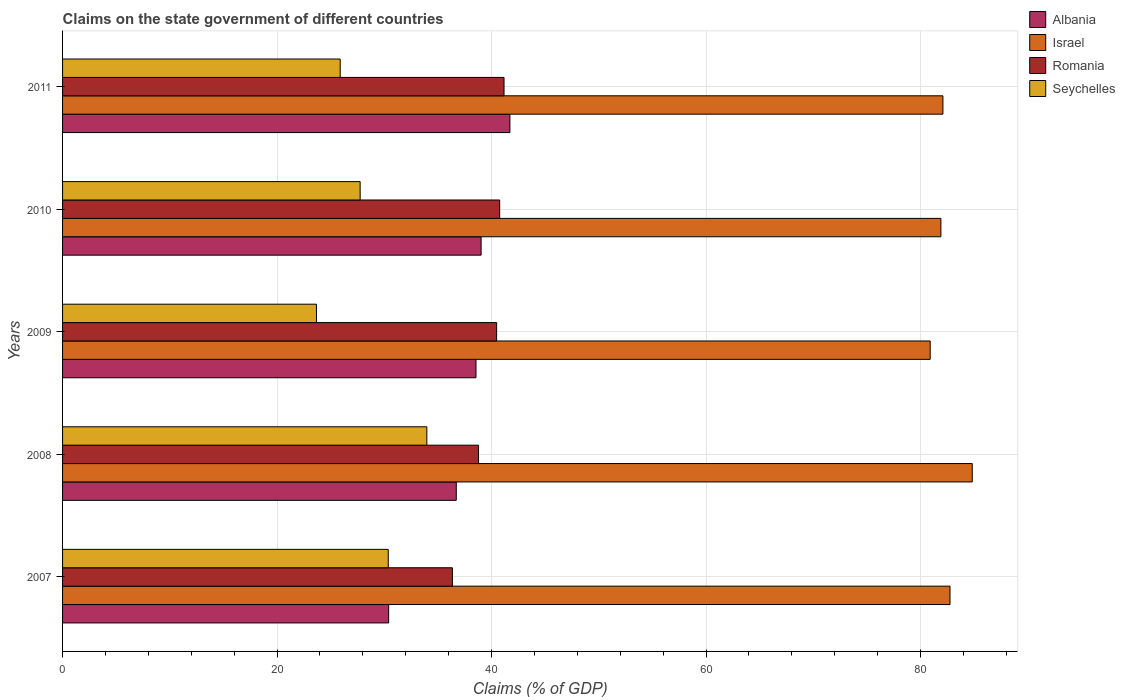How many groups of bars are there?
Give a very brief answer. 5. Are the number of bars on each tick of the Y-axis equal?
Make the answer very short. Yes. What is the percentage of GDP claimed on the state government in Israel in 2007?
Provide a short and direct response. 82.75. Across all years, what is the maximum percentage of GDP claimed on the state government in Seychelles?
Keep it short and to the point. 33.96. Across all years, what is the minimum percentage of GDP claimed on the state government in Israel?
Your response must be concise. 80.9. In which year was the percentage of GDP claimed on the state government in Romania maximum?
Provide a succinct answer. 2011. What is the total percentage of GDP claimed on the state government in Israel in the graph?
Make the answer very short. 412.44. What is the difference between the percentage of GDP claimed on the state government in Seychelles in 2007 and that in 2010?
Keep it short and to the point. 2.62. What is the difference between the percentage of GDP claimed on the state government in Israel in 2009 and the percentage of GDP claimed on the state government in Seychelles in 2007?
Make the answer very short. 50.53. What is the average percentage of GDP claimed on the state government in Seychelles per year?
Your answer should be very brief. 28.33. In the year 2011, what is the difference between the percentage of GDP claimed on the state government in Albania and percentage of GDP claimed on the state government in Romania?
Offer a terse response. 0.55. What is the ratio of the percentage of GDP claimed on the state government in Albania in 2010 to that in 2011?
Provide a short and direct response. 0.94. What is the difference between the highest and the second highest percentage of GDP claimed on the state government in Romania?
Your answer should be compact. 0.41. What is the difference between the highest and the lowest percentage of GDP claimed on the state government in Romania?
Your answer should be very brief. 4.82. In how many years, is the percentage of GDP claimed on the state government in Albania greater than the average percentage of GDP claimed on the state government in Albania taken over all years?
Your answer should be very brief. 3. What does the 3rd bar from the bottom in 2011 represents?
Make the answer very short. Romania. Is it the case that in every year, the sum of the percentage of GDP claimed on the state government in Israel and percentage of GDP claimed on the state government in Romania is greater than the percentage of GDP claimed on the state government in Seychelles?
Offer a terse response. Yes. Are all the bars in the graph horizontal?
Keep it short and to the point. Yes. How many years are there in the graph?
Your answer should be compact. 5. What is the difference between two consecutive major ticks on the X-axis?
Provide a succinct answer. 20. Does the graph contain any zero values?
Give a very brief answer. No. Does the graph contain grids?
Give a very brief answer. Yes. How many legend labels are there?
Your response must be concise. 4. What is the title of the graph?
Give a very brief answer. Claims on the state government of different countries. Does "Slovak Republic" appear as one of the legend labels in the graph?
Keep it short and to the point. No. What is the label or title of the X-axis?
Provide a succinct answer. Claims (% of GDP). What is the label or title of the Y-axis?
Offer a very short reply. Years. What is the Claims (% of GDP) of Albania in 2007?
Give a very brief answer. 30.41. What is the Claims (% of GDP) in Israel in 2007?
Give a very brief answer. 82.75. What is the Claims (% of GDP) of Romania in 2007?
Provide a short and direct response. 36.35. What is the Claims (% of GDP) of Seychelles in 2007?
Keep it short and to the point. 30.37. What is the Claims (% of GDP) of Albania in 2008?
Ensure brevity in your answer.  36.71. What is the Claims (% of GDP) of Israel in 2008?
Your answer should be compact. 84.82. What is the Claims (% of GDP) of Romania in 2008?
Provide a succinct answer. 38.78. What is the Claims (% of GDP) in Seychelles in 2008?
Make the answer very short. 33.96. What is the Claims (% of GDP) of Albania in 2009?
Offer a very short reply. 38.55. What is the Claims (% of GDP) in Israel in 2009?
Your response must be concise. 80.9. What is the Claims (% of GDP) of Romania in 2009?
Your answer should be compact. 40.47. What is the Claims (% of GDP) in Seychelles in 2009?
Offer a very short reply. 23.67. What is the Claims (% of GDP) of Albania in 2010?
Ensure brevity in your answer.  39.02. What is the Claims (% of GDP) of Israel in 2010?
Give a very brief answer. 81.89. What is the Claims (% of GDP) in Romania in 2010?
Your answer should be very brief. 40.76. What is the Claims (% of GDP) in Seychelles in 2010?
Ensure brevity in your answer.  27.75. What is the Claims (% of GDP) in Albania in 2011?
Your answer should be very brief. 41.71. What is the Claims (% of GDP) of Israel in 2011?
Make the answer very short. 82.08. What is the Claims (% of GDP) in Romania in 2011?
Keep it short and to the point. 41.16. What is the Claims (% of GDP) of Seychelles in 2011?
Ensure brevity in your answer.  25.89. Across all years, what is the maximum Claims (% of GDP) in Albania?
Offer a terse response. 41.71. Across all years, what is the maximum Claims (% of GDP) in Israel?
Keep it short and to the point. 84.82. Across all years, what is the maximum Claims (% of GDP) in Romania?
Keep it short and to the point. 41.16. Across all years, what is the maximum Claims (% of GDP) in Seychelles?
Offer a very short reply. 33.96. Across all years, what is the minimum Claims (% of GDP) in Albania?
Provide a succinct answer. 30.41. Across all years, what is the minimum Claims (% of GDP) of Israel?
Provide a succinct answer. 80.9. Across all years, what is the minimum Claims (% of GDP) of Romania?
Provide a succinct answer. 36.35. Across all years, what is the minimum Claims (% of GDP) in Seychelles?
Your response must be concise. 23.67. What is the total Claims (% of GDP) in Albania in the graph?
Your answer should be compact. 186.4. What is the total Claims (% of GDP) of Israel in the graph?
Ensure brevity in your answer.  412.44. What is the total Claims (% of GDP) in Romania in the graph?
Offer a very short reply. 197.52. What is the total Claims (% of GDP) of Seychelles in the graph?
Keep it short and to the point. 141.64. What is the difference between the Claims (% of GDP) of Albania in 2007 and that in 2008?
Your response must be concise. -6.3. What is the difference between the Claims (% of GDP) in Israel in 2007 and that in 2008?
Your answer should be very brief. -2.07. What is the difference between the Claims (% of GDP) in Romania in 2007 and that in 2008?
Provide a short and direct response. -2.44. What is the difference between the Claims (% of GDP) of Seychelles in 2007 and that in 2008?
Offer a very short reply. -3.6. What is the difference between the Claims (% of GDP) of Albania in 2007 and that in 2009?
Make the answer very short. -8.14. What is the difference between the Claims (% of GDP) in Israel in 2007 and that in 2009?
Your response must be concise. 1.85. What is the difference between the Claims (% of GDP) of Romania in 2007 and that in 2009?
Offer a very short reply. -4.12. What is the difference between the Claims (% of GDP) in Seychelles in 2007 and that in 2009?
Keep it short and to the point. 6.69. What is the difference between the Claims (% of GDP) in Albania in 2007 and that in 2010?
Give a very brief answer. -8.62. What is the difference between the Claims (% of GDP) in Israel in 2007 and that in 2010?
Keep it short and to the point. 0.85. What is the difference between the Claims (% of GDP) of Romania in 2007 and that in 2010?
Provide a short and direct response. -4.41. What is the difference between the Claims (% of GDP) in Seychelles in 2007 and that in 2010?
Offer a terse response. 2.62. What is the difference between the Claims (% of GDP) of Albania in 2007 and that in 2011?
Offer a very short reply. -11.31. What is the difference between the Claims (% of GDP) in Israel in 2007 and that in 2011?
Your answer should be very brief. 0.66. What is the difference between the Claims (% of GDP) of Romania in 2007 and that in 2011?
Keep it short and to the point. -4.82. What is the difference between the Claims (% of GDP) in Seychelles in 2007 and that in 2011?
Your answer should be compact. 4.48. What is the difference between the Claims (% of GDP) of Albania in 2008 and that in 2009?
Provide a short and direct response. -1.84. What is the difference between the Claims (% of GDP) of Israel in 2008 and that in 2009?
Ensure brevity in your answer.  3.92. What is the difference between the Claims (% of GDP) of Romania in 2008 and that in 2009?
Offer a very short reply. -1.69. What is the difference between the Claims (% of GDP) of Seychelles in 2008 and that in 2009?
Provide a succinct answer. 10.29. What is the difference between the Claims (% of GDP) in Albania in 2008 and that in 2010?
Your response must be concise. -2.31. What is the difference between the Claims (% of GDP) in Israel in 2008 and that in 2010?
Your response must be concise. 2.92. What is the difference between the Claims (% of GDP) in Romania in 2008 and that in 2010?
Provide a short and direct response. -1.97. What is the difference between the Claims (% of GDP) in Seychelles in 2008 and that in 2010?
Your answer should be compact. 6.22. What is the difference between the Claims (% of GDP) of Albania in 2008 and that in 2011?
Your answer should be very brief. -5. What is the difference between the Claims (% of GDP) of Israel in 2008 and that in 2011?
Your response must be concise. 2.73. What is the difference between the Claims (% of GDP) in Romania in 2008 and that in 2011?
Ensure brevity in your answer.  -2.38. What is the difference between the Claims (% of GDP) of Seychelles in 2008 and that in 2011?
Ensure brevity in your answer.  8.08. What is the difference between the Claims (% of GDP) of Albania in 2009 and that in 2010?
Your response must be concise. -0.48. What is the difference between the Claims (% of GDP) of Israel in 2009 and that in 2010?
Your answer should be compact. -1. What is the difference between the Claims (% of GDP) in Romania in 2009 and that in 2010?
Offer a very short reply. -0.28. What is the difference between the Claims (% of GDP) in Seychelles in 2009 and that in 2010?
Make the answer very short. -4.07. What is the difference between the Claims (% of GDP) in Albania in 2009 and that in 2011?
Your answer should be very brief. -3.16. What is the difference between the Claims (% of GDP) in Israel in 2009 and that in 2011?
Your response must be concise. -1.19. What is the difference between the Claims (% of GDP) of Romania in 2009 and that in 2011?
Your answer should be compact. -0.69. What is the difference between the Claims (% of GDP) in Seychelles in 2009 and that in 2011?
Your answer should be compact. -2.21. What is the difference between the Claims (% of GDP) of Albania in 2010 and that in 2011?
Provide a short and direct response. -2.69. What is the difference between the Claims (% of GDP) of Israel in 2010 and that in 2011?
Keep it short and to the point. -0.19. What is the difference between the Claims (% of GDP) of Romania in 2010 and that in 2011?
Keep it short and to the point. -0.41. What is the difference between the Claims (% of GDP) in Seychelles in 2010 and that in 2011?
Provide a short and direct response. 1.86. What is the difference between the Claims (% of GDP) of Albania in 2007 and the Claims (% of GDP) of Israel in 2008?
Ensure brevity in your answer.  -54.41. What is the difference between the Claims (% of GDP) in Albania in 2007 and the Claims (% of GDP) in Romania in 2008?
Ensure brevity in your answer.  -8.38. What is the difference between the Claims (% of GDP) of Albania in 2007 and the Claims (% of GDP) of Seychelles in 2008?
Keep it short and to the point. -3.56. What is the difference between the Claims (% of GDP) of Israel in 2007 and the Claims (% of GDP) of Romania in 2008?
Ensure brevity in your answer.  43.96. What is the difference between the Claims (% of GDP) of Israel in 2007 and the Claims (% of GDP) of Seychelles in 2008?
Provide a succinct answer. 48.78. What is the difference between the Claims (% of GDP) of Romania in 2007 and the Claims (% of GDP) of Seychelles in 2008?
Offer a terse response. 2.38. What is the difference between the Claims (% of GDP) in Albania in 2007 and the Claims (% of GDP) in Israel in 2009?
Make the answer very short. -50.49. What is the difference between the Claims (% of GDP) of Albania in 2007 and the Claims (% of GDP) of Romania in 2009?
Offer a very short reply. -10.07. What is the difference between the Claims (% of GDP) of Albania in 2007 and the Claims (% of GDP) of Seychelles in 2009?
Provide a short and direct response. 6.73. What is the difference between the Claims (% of GDP) in Israel in 2007 and the Claims (% of GDP) in Romania in 2009?
Make the answer very short. 42.27. What is the difference between the Claims (% of GDP) in Israel in 2007 and the Claims (% of GDP) in Seychelles in 2009?
Keep it short and to the point. 59.07. What is the difference between the Claims (% of GDP) in Romania in 2007 and the Claims (% of GDP) in Seychelles in 2009?
Your answer should be compact. 12.67. What is the difference between the Claims (% of GDP) of Albania in 2007 and the Claims (% of GDP) of Israel in 2010?
Your response must be concise. -51.49. What is the difference between the Claims (% of GDP) in Albania in 2007 and the Claims (% of GDP) in Romania in 2010?
Give a very brief answer. -10.35. What is the difference between the Claims (% of GDP) of Albania in 2007 and the Claims (% of GDP) of Seychelles in 2010?
Give a very brief answer. 2.66. What is the difference between the Claims (% of GDP) of Israel in 2007 and the Claims (% of GDP) of Romania in 2010?
Give a very brief answer. 41.99. What is the difference between the Claims (% of GDP) of Israel in 2007 and the Claims (% of GDP) of Seychelles in 2010?
Your answer should be very brief. 55. What is the difference between the Claims (% of GDP) in Romania in 2007 and the Claims (% of GDP) in Seychelles in 2010?
Provide a short and direct response. 8.6. What is the difference between the Claims (% of GDP) in Albania in 2007 and the Claims (% of GDP) in Israel in 2011?
Your answer should be very brief. -51.68. What is the difference between the Claims (% of GDP) of Albania in 2007 and the Claims (% of GDP) of Romania in 2011?
Ensure brevity in your answer.  -10.76. What is the difference between the Claims (% of GDP) of Albania in 2007 and the Claims (% of GDP) of Seychelles in 2011?
Keep it short and to the point. 4.52. What is the difference between the Claims (% of GDP) in Israel in 2007 and the Claims (% of GDP) in Romania in 2011?
Offer a terse response. 41.58. What is the difference between the Claims (% of GDP) in Israel in 2007 and the Claims (% of GDP) in Seychelles in 2011?
Give a very brief answer. 56.86. What is the difference between the Claims (% of GDP) in Romania in 2007 and the Claims (% of GDP) in Seychelles in 2011?
Your answer should be very brief. 10.46. What is the difference between the Claims (% of GDP) in Albania in 2008 and the Claims (% of GDP) in Israel in 2009?
Ensure brevity in your answer.  -44.19. What is the difference between the Claims (% of GDP) of Albania in 2008 and the Claims (% of GDP) of Romania in 2009?
Keep it short and to the point. -3.76. What is the difference between the Claims (% of GDP) in Albania in 2008 and the Claims (% of GDP) in Seychelles in 2009?
Offer a very short reply. 13.04. What is the difference between the Claims (% of GDP) in Israel in 2008 and the Claims (% of GDP) in Romania in 2009?
Make the answer very short. 44.35. What is the difference between the Claims (% of GDP) of Israel in 2008 and the Claims (% of GDP) of Seychelles in 2009?
Offer a very short reply. 61.14. What is the difference between the Claims (% of GDP) in Romania in 2008 and the Claims (% of GDP) in Seychelles in 2009?
Offer a very short reply. 15.11. What is the difference between the Claims (% of GDP) of Albania in 2008 and the Claims (% of GDP) of Israel in 2010?
Make the answer very short. -45.19. What is the difference between the Claims (% of GDP) of Albania in 2008 and the Claims (% of GDP) of Romania in 2010?
Make the answer very short. -4.05. What is the difference between the Claims (% of GDP) of Albania in 2008 and the Claims (% of GDP) of Seychelles in 2010?
Provide a succinct answer. 8.96. What is the difference between the Claims (% of GDP) in Israel in 2008 and the Claims (% of GDP) in Romania in 2010?
Provide a short and direct response. 44.06. What is the difference between the Claims (% of GDP) in Israel in 2008 and the Claims (% of GDP) in Seychelles in 2010?
Provide a short and direct response. 57.07. What is the difference between the Claims (% of GDP) in Romania in 2008 and the Claims (% of GDP) in Seychelles in 2010?
Provide a short and direct response. 11.04. What is the difference between the Claims (% of GDP) of Albania in 2008 and the Claims (% of GDP) of Israel in 2011?
Ensure brevity in your answer.  -45.38. What is the difference between the Claims (% of GDP) of Albania in 2008 and the Claims (% of GDP) of Romania in 2011?
Provide a succinct answer. -4.45. What is the difference between the Claims (% of GDP) of Albania in 2008 and the Claims (% of GDP) of Seychelles in 2011?
Provide a succinct answer. 10.82. What is the difference between the Claims (% of GDP) of Israel in 2008 and the Claims (% of GDP) of Romania in 2011?
Your answer should be very brief. 43.65. What is the difference between the Claims (% of GDP) of Israel in 2008 and the Claims (% of GDP) of Seychelles in 2011?
Make the answer very short. 58.93. What is the difference between the Claims (% of GDP) of Romania in 2008 and the Claims (% of GDP) of Seychelles in 2011?
Provide a short and direct response. 12.9. What is the difference between the Claims (% of GDP) of Albania in 2009 and the Claims (% of GDP) of Israel in 2010?
Provide a short and direct response. -43.35. What is the difference between the Claims (% of GDP) of Albania in 2009 and the Claims (% of GDP) of Romania in 2010?
Your response must be concise. -2.21. What is the difference between the Claims (% of GDP) of Albania in 2009 and the Claims (% of GDP) of Seychelles in 2010?
Your answer should be very brief. 10.8. What is the difference between the Claims (% of GDP) in Israel in 2009 and the Claims (% of GDP) in Romania in 2010?
Your answer should be very brief. 40.14. What is the difference between the Claims (% of GDP) of Israel in 2009 and the Claims (% of GDP) of Seychelles in 2010?
Provide a succinct answer. 53.15. What is the difference between the Claims (% of GDP) in Romania in 2009 and the Claims (% of GDP) in Seychelles in 2010?
Give a very brief answer. 12.73. What is the difference between the Claims (% of GDP) in Albania in 2009 and the Claims (% of GDP) in Israel in 2011?
Ensure brevity in your answer.  -43.54. What is the difference between the Claims (% of GDP) in Albania in 2009 and the Claims (% of GDP) in Romania in 2011?
Keep it short and to the point. -2.62. What is the difference between the Claims (% of GDP) in Albania in 2009 and the Claims (% of GDP) in Seychelles in 2011?
Ensure brevity in your answer.  12.66. What is the difference between the Claims (% of GDP) of Israel in 2009 and the Claims (% of GDP) of Romania in 2011?
Keep it short and to the point. 39.73. What is the difference between the Claims (% of GDP) of Israel in 2009 and the Claims (% of GDP) of Seychelles in 2011?
Your response must be concise. 55.01. What is the difference between the Claims (% of GDP) of Romania in 2009 and the Claims (% of GDP) of Seychelles in 2011?
Your answer should be compact. 14.58. What is the difference between the Claims (% of GDP) of Albania in 2010 and the Claims (% of GDP) of Israel in 2011?
Provide a short and direct response. -43.06. What is the difference between the Claims (% of GDP) in Albania in 2010 and the Claims (% of GDP) in Romania in 2011?
Provide a short and direct response. -2.14. What is the difference between the Claims (% of GDP) in Albania in 2010 and the Claims (% of GDP) in Seychelles in 2011?
Provide a succinct answer. 13.14. What is the difference between the Claims (% of GDP) of Israel in 2010 and the Claims (% of GDP) of Romania in 2011?
Offer a very short reply. 40.73. What is the difference between the Claims (% of GDP) in Israel in 2010 and the Claims (% of GDP) in Seychelles in 2011?
Your response must be concise. 56.01. What is the difference between the Claims (% of GDP) in Romania in 2010 and the Claims (% of GDP) in Seychelles in 2011?
Keep it short and to the point. 14.87. What is the average Claims (% of GDP) in Albania per year?
Make the answer very short. 37.28. What is the average Claims (% of GDP) in Israel per year?
Your response must be concise. 82.49. What is the average Claims (% of GDP) of Romania per year?
Provide a short and direct response. 39.5. What is the average Claims (% of GDP) in Seychelles per year?
Provide a succinct answer. 28.33. In the year 2007, what is the difference between the Claims (% of GDP) of Albania and Claims (% of GDP) of Israel?
Ensure brevity in your answer.  -52.34. In the year 2007, what is the difference between the Claims (% of GDP) in Albania and Claims (% of GDP) in Romania?
Provide a short and direct response. -5.94. In the year 2007, what is the difference between the Claims (% of GDP) of Albania and Claims (% of GDP) of Seychelles?
Your response must be concise. 0.04. In the year 2007, what is the difference between the Claims (% of GDP) of Israel and Claims (% of GDP) of Romania?
Your answer should be compact. 46.4. In the year 2007, what is the difference between the Claims (% of GDP) in Israel and Claims (% of GDP) in Seychelles?
Offer a terse response. 52.38. In the year 2007, what is the difference between the Claims (% of GDP) in Romania and Claims (% of GDP) in Seychelles?
Keep it short and to the point. 5.98. In the year 2008, what is the difference between the Claims (% of GDP) in Albania and Claims (% of GDP) in Israel?
Your answer should be compact. -48.11. In the year 2008, what is the difference between the Claims (% of GDP) in Albania and Claims (% of GDP) in Romania?
Give a very brief answer. -2.08. In the year 2008, what is the difference between the Claims (% of GDP) in Albania and Claims (% of GDP) in Seychelles?
Your response must be concise. 2.75. In the year 2008, what is the difference between the Claims (% of GDP) in Israel and Claims (% of GDP) in Romania?
Keep it short and to the point. 46.03. In the year 2008, what is the difference between the Claims (% of GDP) in Israel and Claims (% of GDP) in Seychelles?
Offer a very short reply. 50.85. In the year 2008, what is the difference between the Claims (% of GDP) of Romania and Claims (% of GDP) of Seychelles?
Keep it short and to the point. 4.82. In the year 2009, what is the difference between the Claims (% of GDP) in Albania and Claims (% of GDP) in Israel?
Make the answer very short. -42.35. In the year 2009, what is the difference between the Claims (% of GDP) in Albania and Claims (% of GDP) in Romania?
Make the answer very short. -1.92. In the year 2009, what is the difference between the Claims (% of GDP) in Albania and Claims (% of GDP) in Seychelles?
Offer a terse response. 14.87. In the year 2009, what is the difference between the Claims (% of GDP) of Israel and Claims (% of GDP) of Romania?
Your answer should be very brief. 40.42. In the year 2009, what is the difference between the Claims (% of GDP) in Israel and Claims (% of GDP) in Seychelles?
Keep it short and to the point. 57.22. In the year 2009, what is the difference between the Claims (% of GDP) of Romania and Claims (% of GDP) of Seychelles?
Keep it short and to the point. 16.8. In the year 2010, what is the difference between the Claims (% of GDP) of Albania and Claims (% of GDP) of Israel?
Provide a short and direct response. -42.87. In the year 2010, what is the difference between the Claims (% of GDP) of Albania and Claims (% of GDP) of Romania?
Keep it short and to the point. -1.73. In the year 2010, what is the difference between the Claims (% of GDP) in Albania and Claims (% of GDP) in Seychelles?
Your answer should be very brief. 11.28. In the year 2010, what is the difference between the Claims (% of GDP) in Israel and Claims (% of GDP) in Romania?
Ensure brevity in your answer.  41.14. In the year 2010, what is the difference between the Claims (% of GDP) of Israel and Claims (% of GDP) of Seychelles?
Offer a very short reply. 54.15. In the year 2010, what is the difference between the Claims (% of GDP) of Romania and Claims (% of GDP) of Seychelles?
Provide a short and direct response. 13.01. In the year 2011, what is the difference between the Claims (% of GDP) of Albania and Claims (% of GDP) of Israel?
Keep it short and to the point. -40.37. In the year 2011, what is the difference between the Claims (% of GDP) in Albania and Claims (% of GDP) in Romania?
Your response must be concise. 0.55. In the year 2011, what is the difference between the Claims (% of GDP) in Albania and Claims (% of GDP) in Seychelles?
Your response must be concise. 15.82. In the year 2011, what is the difference between the Claims (% of GDP) of Israel and Claims (% of GDP) of Romania?
Your answer should be very brief. 40.92. In the year 2011, what is the difference between the Claims (% of GDP) of Israel and Claims (% of GDP) of Seychelles?
Give a very brief answer. 56.2. In the year 2011, what is the difference between the Claims (% of GDP) of Romania and Claims (% of GDP) of Seychelles?
Provide a short and direct response. 15.28. What is the ratio of the Claims (% of GDP) in Albania in 2007 to that in 2008?
Give a very brief answer. 0.83. What is the ratio of the Claims (% of GDP) of Israel in 2007 to that in 2008?
Ensure brevity in your answer.  0.98. What is the ratio of the Claims (% of GDP) in Romania in 2007 to that in 2008?
Offer a very short reply. 0.94. What is the ratio of the Claims (% of GDP) in Seychelles in 2007 to that in 2008?
Make the answer very short. 0.89. What is the ratio of the Claims (% of GDP) in Albania in 2007 to that in 2009?
Give a very brief answer. 0.79. What is the ratio of the Claims (% of GDP) in Israel in 2007 to that in 2009?
Make the answer very short. 1.02. What is the ratio of the Claims (% of GDP) in Romania in 2007 to that in 2009?
Give a very brief answer. 0.9. What is the ratio of the Claims (% of GDP) in Seychelles in 2007 to that in 2009?
Your answer should be compact. 1.28. What is the ratio of the Claims (% of GDP) of Albania in 2007 to that in 2010?
Keep it short and to the point. 0.78. What is the ratio of the Claims (% of GDP) of Israel in 2007 to that in 2010?
Offer a very short reply. 1.01. What is the ratio of the Claims (% of GDP) in Romania in 2007 to that in 2010?
Your answer should be very brief. 0.89. What is the ratio of the Claims (% of GDP) of Seychelles in 2007 to that in 2010?
Offer a terse response. 1.09. What is the ratio of the Claims (% of GDP) in Albania in 2007 to that in 2011?
Make the answer very short. 0.73. What is the ratio of the Claims (% of GDP) in Israel in 2007 to that in 2011?
Provide a short and direct response. 1.01. What is the ratio of the Claims (% of GDP) of Romania in 2007 to that in 2011?
Give a very brief answer. 0.88. What is the ratio of the Claims (% of GDP) in Seychelles in 2007 to that in 2011?
Your response must be concise. 1.17. What is the ratio of the Claims (% of GDP) of Albania in 2008 to that in 2009?
Offer a very short reply. 0.95. What is the ratio of the Claims (% of GDP) in Israel in 2008 to that in 2009?
Your answer should be compact. 1.05. What is the ratio of the Claims (% of GDP) of Romania in 2008 to that in 2009?
Provide a short and direct response. 0.96. What is the ratio of the Claims (% of GDP) in Seychelles in 2008 to that in 2009?
Provide a succinct answer. 1.43. What is the ratio of the Claims (% of GDP) of Albania in 2008 to that in 2010?
Your response must be concise. 0.94. What is the ratio of the Claims (% of GDP) in Israel in 2008 to that in 2010?
Provide a succinct answer. 1.04. What is the ratio of the Claims (% of GDP) in Romania in 2008 to that in 2010?
Your answer should be very brief. 0.95. What is the ratio of the Claims (% of GDP) in Seychelles in 2008 to that in 2010?
Provide a succinct answer. 1.22. What is the ratio of the Claims (% of GDP) in Albania in 2008 to that in 2011?
Offer a very short reply. 0.88. What is the ratio of the Claims (% of GDP) in Romania in 2008 to that in 2011?
Give a very brief answer. 0.94. What is the ratio of the Claims (% of GDP) in Seychelles in 2008 to that in 2011?
Give a very brief answer. 1.31. What is the ratio of the Claims (% of GDP) of Albania in 2009 to that in 2010?
Your answer should be very brief. 0.99. What is the ratio of the Claims (% of GDP) in Israel in 2009 to that in 2010?
Provide a short and direct response. 0.99. What is the ratio of the Claims (% of GDP) in Romania in 2009 to that in 2010?
Your response must be concise. 0.99. What is the ratio of the Claims (% of GDP) of Seychelles in 2009 to that in 2010?
Offer a very short reply. 0.85. What is the ratio of the Claims (% of GDP) of Albania in 2009 to that in 2011?
Provide a succinct answer. 0.92. What is the ratio of the Claims (% of GDP) of Israel in 2009 to that in 2011?
Your response must be concise. 0.99. What is the ratio of the Claims (% of GDP) of Romania in 2009 to that in 2011?
Offer a terse response. 0.98. What is the ratio of the Claims (% of GDP) of Seychelles in 2009 to that in 2011?
Keep it short and to the point. 0.91. What is the ratio of the Claims (% of GDP) in Albania in 2010 to that in 2011?
Ensure brevity in your answer.  0.94. What is the ratio of the Claims (% of GDP) of Seychelles in 2010 to that in 2011?
Provide a short and direct response. 1.07. What is the difference between the highest and the second highest Claims (% of GDP) in Albania?
Make the answer very short. 2.69. What is the difference between the highest and the second highest Claims (% of GDP) in Israel?
Your response must be concise. 2.07. What is the difference between the highest and the second highest Claims (% of GDP) of Romania?
Give a very brief answer. 0.41. What is the difference between the highest and the second highest Claims (% of GDP) in Seychelles?
Offer a very short reply. 3.6. What is the difference between the highest and the lowest Claims (% of GDP) in Albania?
Offer a very short reply. 11.31. What is the difference between the highest and the lowest Claims (% of GDP) in Israel?
Your answer should be very brief. 3.92. What is the difference between the highest and the lowest Claims (% of GDP) in Romania?
Keep it short and to the point. 4.82. What is the difference between the highest and the lowest Claims (% of GDP) of Seychelles?
Offer a terse response. 10.29. 